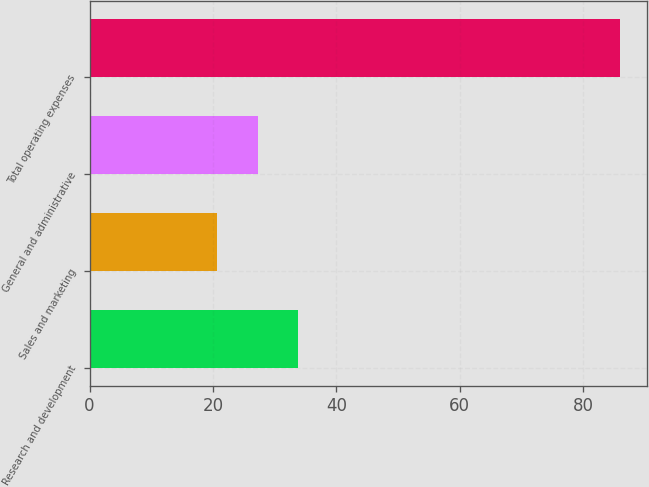Convert chart to OTSL. <chart><loc_0><loc_0><loc_500><loc_500><bar_chart><fcel>Research and development<fcel>Sales and marketing<fcel>General and administrative<fcel>Total operating expenses<nl><fcel>33.76<fcel>20.7<fcel>27.23<fcel>86<nl></chart> 